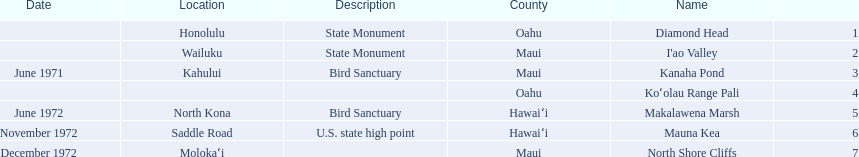Which national natural landmarks in hawaii are in oahu county? Diamond Head, Koʻolau Range Pali. Of these landmarks, which one is listed without a location? Koʻolau Range Pali. 